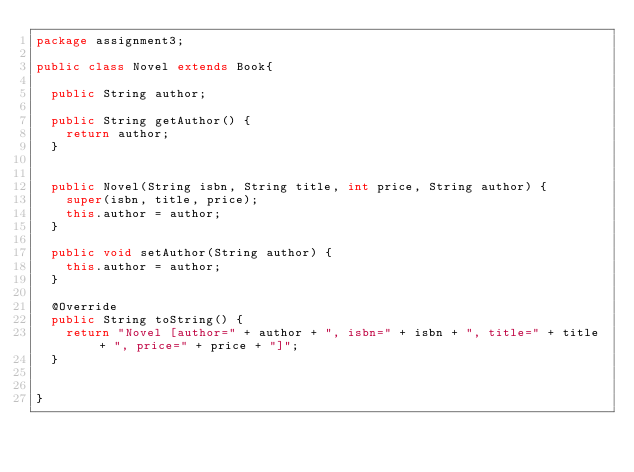<code> <loc_0><loc_0><loc_500><loc_500><_Java_>package assignment3;

public class Novel extends Book{

	public String author;

	public String getAuthor() {
		return author;
	}


	public Novel(String isbn, String title, int price, String author) {
		super(isbn, title, price);
		this.author = author;
	}

	public void setAuthor(String author) {
		this.author = author;
	}

	@Override
	public String toString() {
		return "Novel [author=" + author + ", isbn=" + isbn + ", title=" + title + ", price=" + price + "]";
	}


}
</code> 